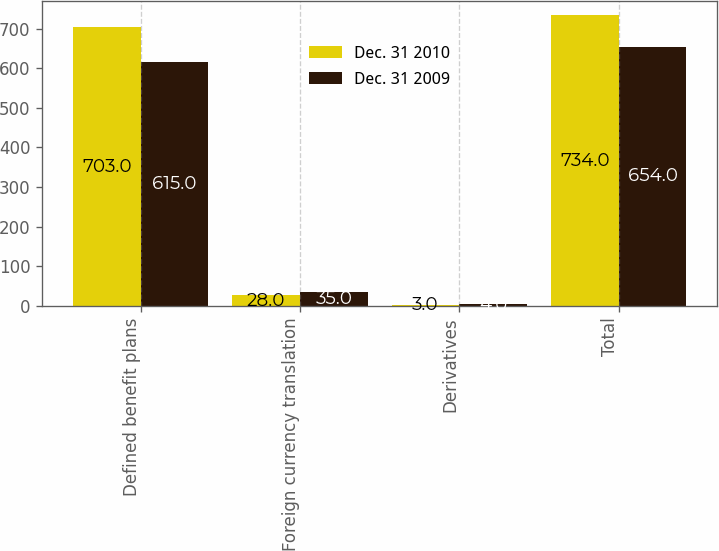Convert chart. <chart><loc_0><loc_0><loc_500><loc_500><stacked_bar_chart><ecel><fcel>Defined benefit plans<fcel>Foreign currency translation<fcel>Derivatives<fcel>Total<nl><fcel>Dec. 31 2010<fcel>703<fcel>28<fcel>3<fcel>734<nl><fcel>Dec. 31 2009<fcel>615<fcel>35<fcel>4<fcel>654<nl></chart> 